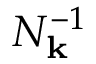Convert formula to latex. <formula><loc_0><loc_0><loc_500><loc_500>N _ { k } ^ { - 1 }</formula> 